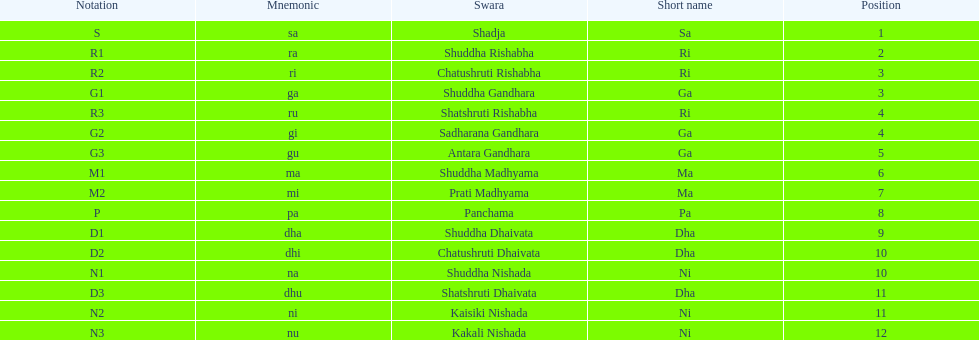Help me parse the entirety of this table. {'header': ['Notation', 'Mnemonic', 'Swara', 'Short name', 'Position'], 'rows': [['S', 'sa', 'Shadja', 'Sa', '1'], ['R1', 'ra', 'Shuddha Rishabha', 'Ri', '2'], ['R2', 'ri', 'Chatushruti Rishabha', 'Ri', '3'], ['G1', 'ga', 'Shuddha Gandhara', 'Ga', '3'], ['R3', 'ru', 'Shatshruti Rishabha', 'Ri', '4'], ['G2', 'gi', 'Sadharana Gandhara', 'Ga', '4'], ['G3', 'gu', 'Antara Gandhara', 'Ga', '5'], ['M1', 'ma', 'Shuddha Madhyama', 'Ma', '6'], ['M2', 'mi', 'Prati Madhyama', 'Ma', '7'], ['P', 'pa', 'Panchama', 'Pa', '8'], ['D1', 'dha', 'Shuddha Dhaivata', 'Dha', '9'], ['D2', 'dhi', 'Chatushruti Dhaivata', 'Dha', '10'], ['N1', 'na', 'Shuddha Nishada', 'Ni', '10'], ['D3', 'dhu', 'Shatshruti Dhaivata', 'Dha', '11'], ['N2', 'ni', 'Kaisiki Nishada', 'Ni', '11'], ['N3', 'nu', 'Kakali Nishada', 'Ni', '12']]} On average how many of the swara have a short name that begin with d or g? 6. 